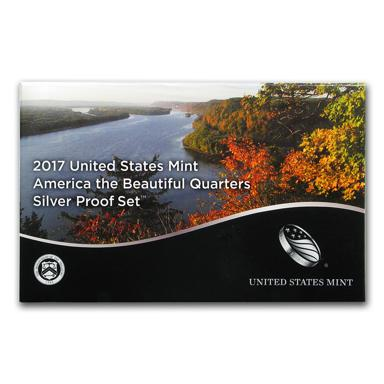What kind of collector would be interested in purchasing this proof set? This 2017 Silver Proof Set would appeal to numismatists who specialize in modern collectible coins, as well as enthusiasts of American heritage and history. Collectors who have a particular interest in the 'America the Beautiful' quarters series, which celebrates the nation's natural wonders and historical sites, would find this set particularly enticing. 